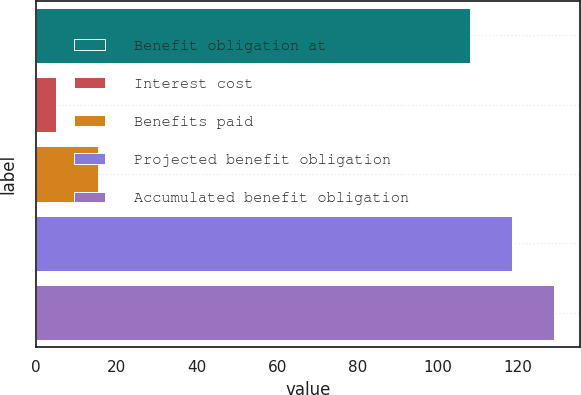Convert chart to OTSL. <chart><loc_0><loc_0><loc_500><loc_500><bar_chart><fcel>Benefit obligation at<fcel>Interest cost<fcel>Benefits paid<fcel>Projected benefit obligation<fcel>Accumulated benefit obligation<nl><fcel>108<fcel>5<fcel>15.5<fcel>118.5<fcel>129<nl></chart> 